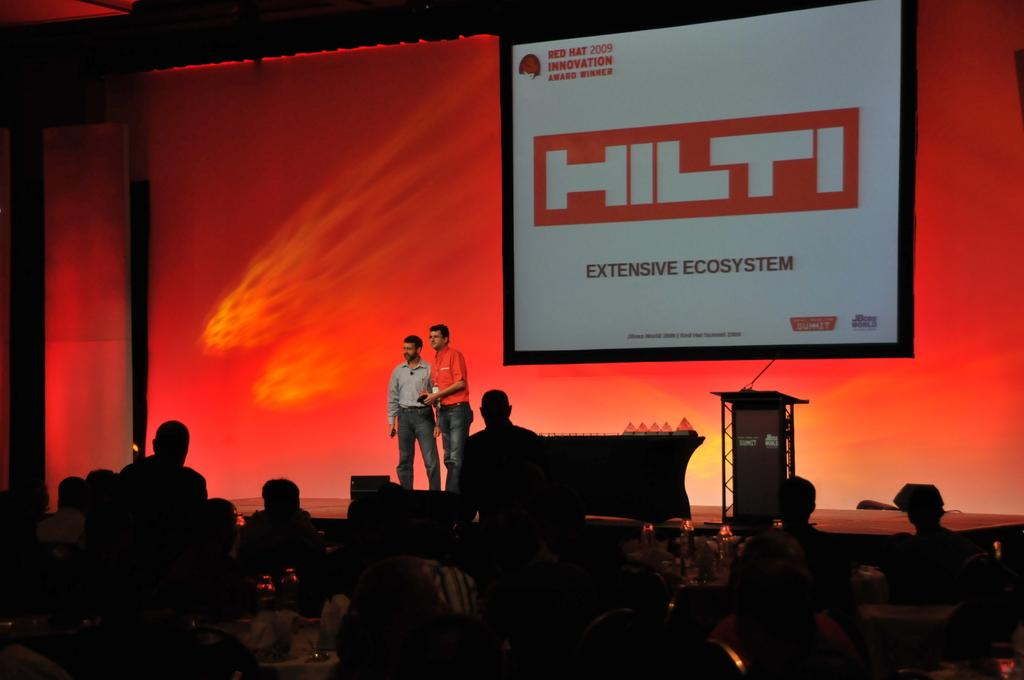How many people are on the stage in the image? There are two persons standing on the stage. What objects are present on the stage? There is a table and a speech desk on the stage. What can be seen in the background of the image? There is a projector screen and a red banner in the background. Can you see any cherries on the table in the image? There are no cherries present on the table in the image. Is there a boot visible on the stage in the image? There is no boot visible on the stage in the image. 